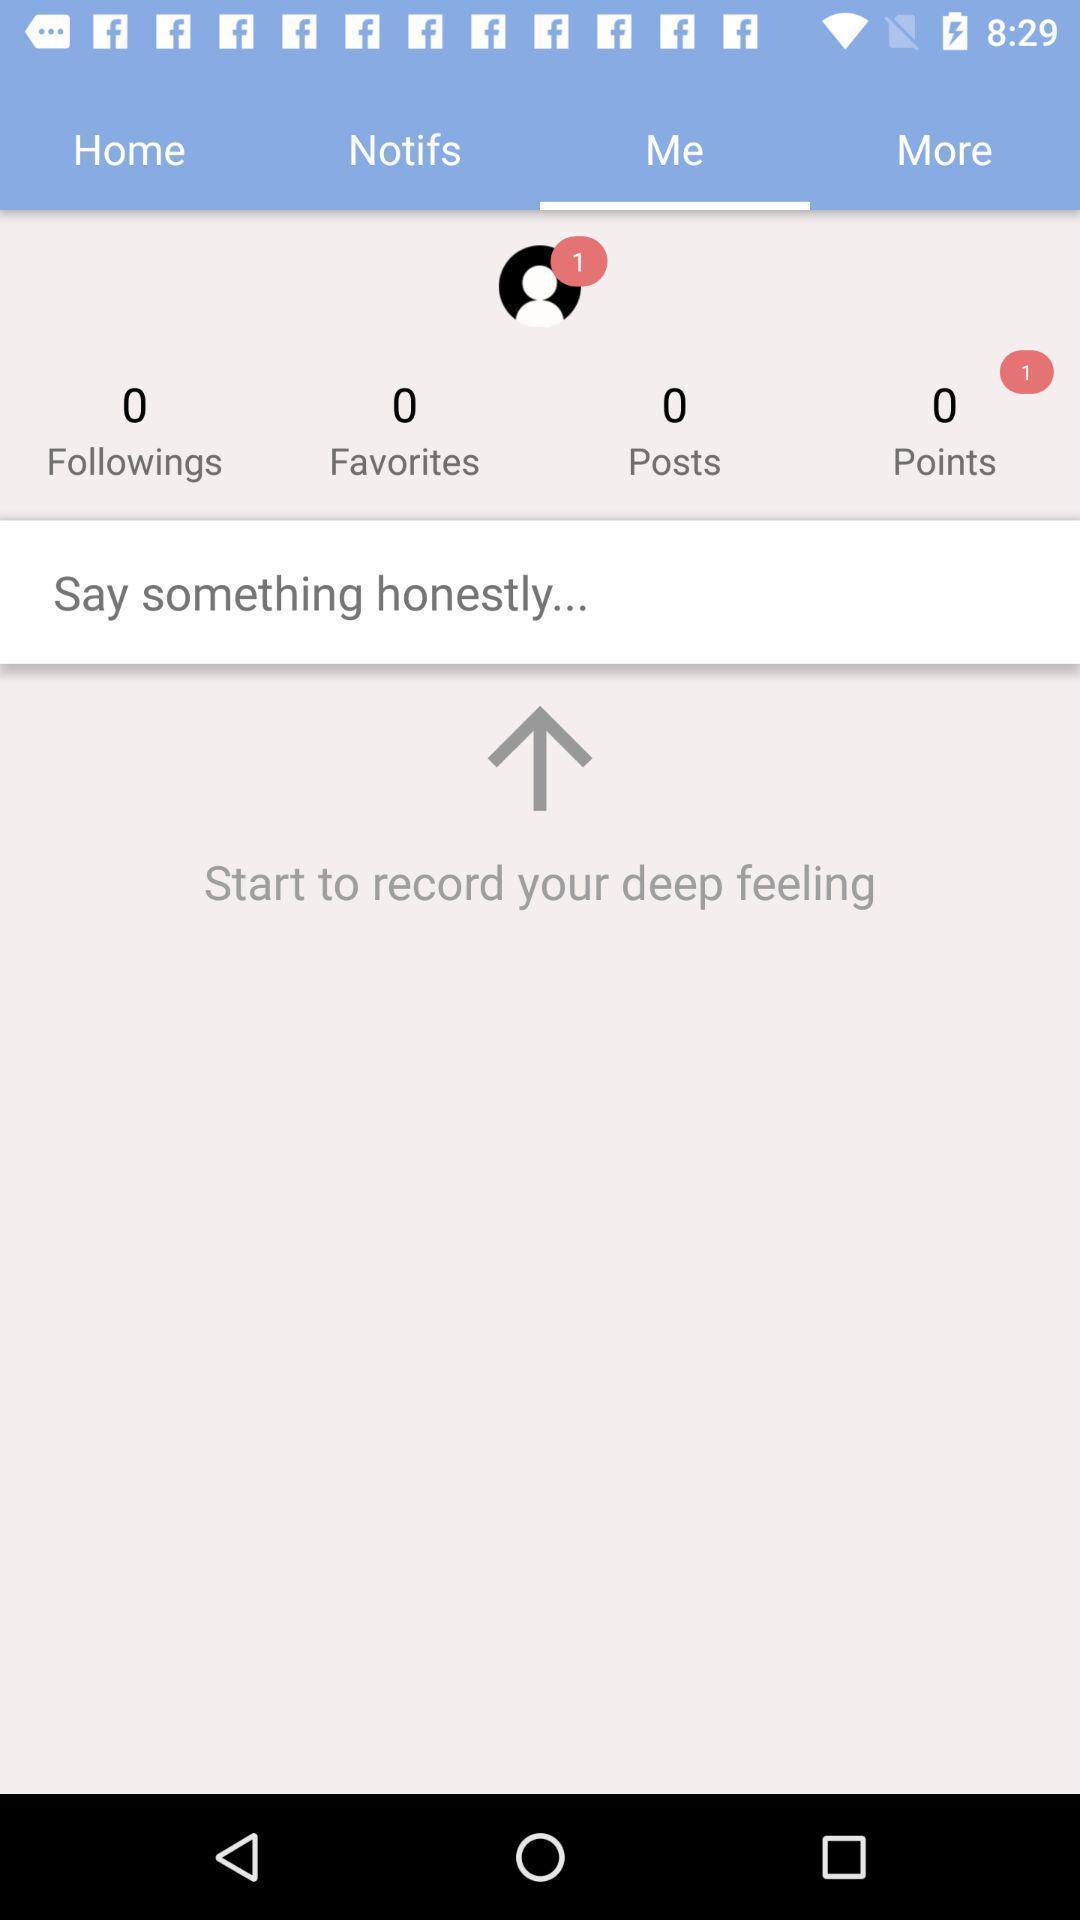Describe this image in words. Profile of a person in a social app. 